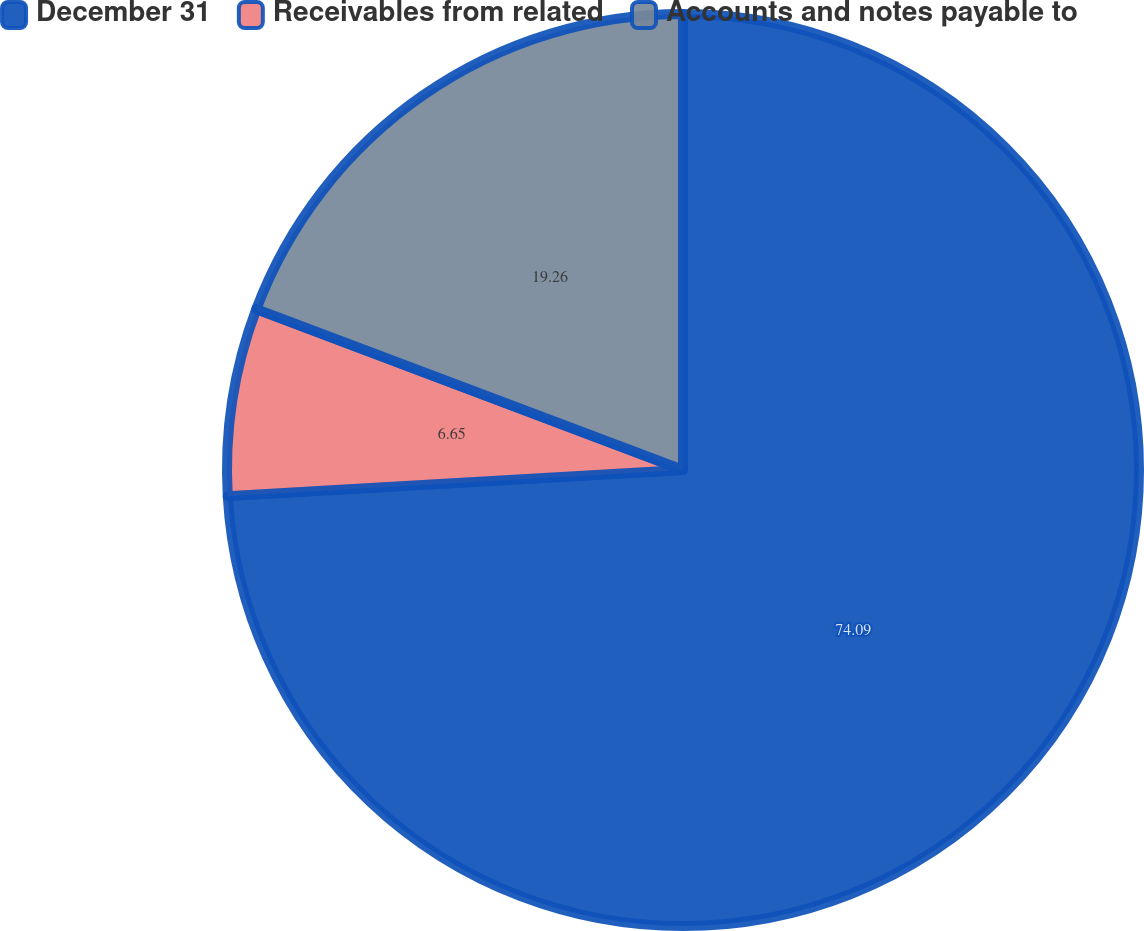<chart> <loc_0><loc_0><loc_500><loc_500><pie_chart><fcel>December 31<fcel>Receivables from related<fcel>Accounts and notes payable to<nl><fcel>74.08%<fcel>6.65%<fcel>19.26%<nl></chart> 